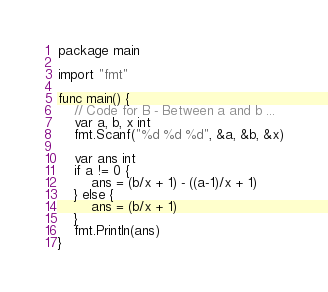Convert code to text. <code><loc_0><loc_0><loc_500><loc_500><_Go_>package main

import "fmt"

func main() {
	// Code for B - Between a and b ...
	var a, b, x int
	fmt.Scanf("%d %d %d", &a, &b, &x)

	var ans int
	if a != 0 {
		ans = (b/x + 1) - ((a-1)/x + 1)
	} else {
		ans = (b/x + 1)
	}
	fmt.Println(ans)
}
</code> 